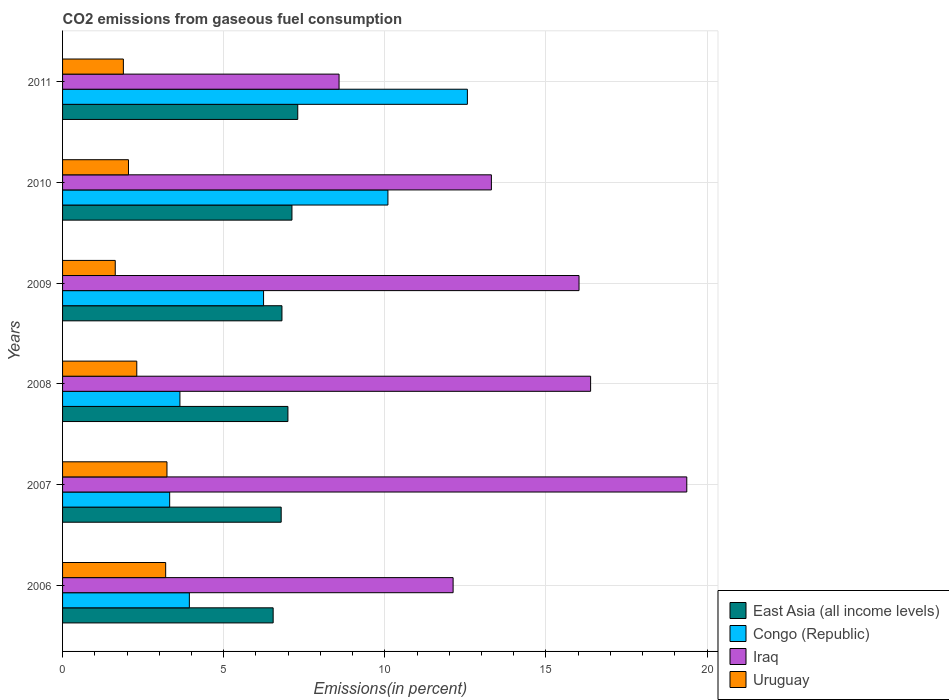How many different coloured bars are there?
Offer a very short reply. 4. How many groups of bars are there?
Ensure brevity in your answer.  6. How many bars are there on the 2nd tick from the bottom?
Offer a very short reply. 4. What is the label of the 1st group of bars from the top?
Keep it short and to the point. 2011. What is the total CO2 emitted in Congo (Republic) in 2009?
Give a very brief answer. 6.24. Across all years, what is the maximum total CO2 emitted in East Asia (all income levels)?
Ensure brevity in your answer.  7.3. Across all years, what is the minimum total CO2 emitted in Uruguay?
Keep it short and to the point. 1.63. In which year was the total CO2 emitted in East Asia (all income levels) maximum?
Offer a very short reply. 2011. What is the total total CO2 emitted in Iraq in the graph?
Ensure brevity in your answer.  85.78. What is the difference between the total CO2 emitted in Uruguay in 2007 and that in 2011?
Keep it short and to the point. 1.35. What is the difference between the total CO2 emitted in Iraq in 2006 and the total CO2 emitted in East Asia (all income levels) in 2007?
Give a very brief answer. 5.33. What is the average total CO2 emitted in Congo (Republic) per year?
Your answer should be compact. 6.63. In the year 2007, what is the difference between the total CO2 emitted in Uruguay and total CO2 emitted in Congo (Republic)?
Give a very brief answer. -0.08. In how many years, is the total CO2 emitted in Congo (Republic) greater than 13 %?
Offer a very short reply. 0. What is the ratio of the total CO2 emitted in Iraq in 2006 to that in 2008?
Keep it short and to the point. 0.74. Is the total CO2 emitted in East Asia (all income levels) in 2009 less than that in 2010?
Make the answer very short. Yes. Is the difference between the total CO2 emitted in Uruguay in 2008 and 2011 greater than the difference between the total CO2 emitted in Congo (Republic) in 2008 and 2011?
Offer a terse response. Yes. What is the difference between the highest and the second highest total CO2 emitted in Uruguay?
Your response must be concise. 0.04. What is the difference between the highest and the lowest total CO2 emitted in Uruguay?
Your response must be concise. 1.6. Is it the case that in every year, the sum of the total CO2 emitted in East Asia (all income levels) and total CO2 emitted in Iraq is greater than the sum of total CO2 emitted in Congo (Republic) and total CO2 emitted in Uruguay?
Keep it short and to the point. No. What does the 1st bar from the top in 2008 represents?
Offer a very short reply. Uruguay. What does the 4th bar from the bottom in 2008 represents?
Offer a terse response. Uruguay. How many bars are there?
Provide a succinct answer. 24. Are all the bars in the graph horizontal?
Offer a terse response. Yes. Are the values on the major ticks of X-axis written in scientific E-notation?
Your answer should be very brief. No. How many legend labels are there?
Make the answer very short. 4. How are the legend labels stacked?
Offer a very short reply. Vertical. What is the title of the graph?
Offer a terse response. CO2 emissions from gaseous fuel consumption. What is the label or title of the X-axis?
Your answer should be very brief. Emissions(in percent). What is the label or title of the Y-axis?
Your response must be concise. Years. What is the Emissions(in percent) in East Asia (all income levels) in 2006?
Your answer should be compact. 6.53. What is the Emissions(in percent) in Congo (Republic) in 2006?
Make the answer very short. 3.93. What is the Emissions(in percent) in Iraq in 2006?
Ensure brevity in your answer.  12.12. What is the Emissions(in percent) in Uruguay in 2006?
Your answer should be compact. 3.2. What is the Emissions(in percent) of East Asia (all income levels) in 2007?
Offer a very short reply. 6.78. What is the Emissions(in percent) of Congo (Republic) in 2007?
Your answer should be very brief. 3.32. What is the Emissions(in percent) of Iraq in 2007?
Give a very brief answer. 19.37. What is the Emissions(in percent) of Uruguay in 2007?
Make the answer very short. 3.24. What is the Emissions(in percent) of East Asia (all income levels) in 2008?
Your response must be concise. 6.99. What is the Emissions(in percent) of Congo (Republic) in 2008?
Your answer should be very brief. 3.64. What is the Emissions(in percent) in Iraq in 2008?
Your answer should be compact. 16.38. What is the Emissions(in percent) of Uruguay in 2008?
Offer a very short reply. 2.3. What is the Emissions(in percent) in East Asia (all income levels) in 2009?
Your answer should be compact. 6.81. What is the Emissions(in percent) in Congo (Republic) in 2009?
Give a very brief answer. 6.24. What is the Emissions(in percent) of Iraq in 2009?
Your answer should be compact. 16.03. What is the Emissions(in percent) in Uruguay in 2009?
Your answer should be compact. 1.63. What is the Emissions(in percent) in East Asia (all income levels) in 2010?
Your response must be concise. 7.12. What is the Emissions(in percent) of Congo (Republic) in 2010?
Make the answer very short. 10.1. What is the Emissions(in percent) of Iraq in 2010?
Keep it short and to the point. 13.31. What is the Emissions(in percent) in Uruguay in 2010?
Your answer should be very brief. 2.05. What is the Emissions(in percent) of East Asia (all income levels) in 2011?
Your answer should be compact. 7.3. What is the Emissions(in percent) of Congo (Republic) in 2011?
Your response must be concise. 12.56. What is the Emissions(in percent) in Iraq in 2011?
Provide a short and direct response. 8.58. What is the Emissions(in percent) of Uruguay in 2011?
Ensure brevity in your answer.  1.89. Across all years, what is the maximum Emissions(in percent) in East Asia (all income levels)?
Your answer should be very brief. 7.3. Across all years, what is the maximum Emissions(in percent) in Congo (Republic)?
Keep it short and to the point. 12.56. Across all years, what is the maximum Emissions(in percent) of Iraq?
Keep it short and to the point. 19.37. Across all years, what is the maximum Emissions(in percent) in Uruguay?
Ensure brevity in your answer.  3.24. Across all years, what is the minimum Emissions(in percent) of East Asia (all income levels)?
Provide a short and direct response. 6.53. Across all years, what is the minimum Emissions(in percent) in Congo (Republic)?
Ensure brevity in your answer.  3.32. Across all years, what is the minimum Emissions(in percent) of Iraq?
Your answer should be very brief. 8.58. Across all years, what is the minimum Emissions(in percent) in Uruguay?
Your answer should be very brief. 1.63. What is the total Emissions(in percent) in East Asia (all income levels) in the graph?
Ensure brevity in your answer.  41.53. What is the total Emissions(in percent) of Congo (Republic) in the graph?
Your answer should be compact. 39.79. What is the total Emissions(in percent) of Iraq in the graph?
Ensure brevity in your answer.  85.78. What is the total Emissions(in percent) in Uruguay in the graph?
Provide a short and direct response. 14.31. What is the difference between the Emissions(in percent) of East Asia (all income levels) in 2006 and that in 2007?
Give a very brief answer. -0.25. What is the difference between the Emissions(in percent) of Congo (Republic) in 2006 and that in 2007?
Offer a very short reply. 0.61. What is the difference between the Emissions(in percent) in Iraq in 2006 and that in 2007?
Your answer should be compact. -7.25. What is the difference between the Emissions(in percent) of Uruguay in 2006 and that in 2007?
Ensure brevity in your answer.  -0.04. What is the difference between the Emissions(in percent) in East Asia (all income levels) in 2006 and that in 2008?
Your response must be concise. -0.46. What is the difference between the Emissions(in percent) of Congo (Republic) in 2006 and that in 2008?
Your response must be concise. 0.29. What is the difference between the Emissions(in percent) in Iraq in 2006 and that in 2008?
Provide a succinct answer. -4.27. What is the difference between the Emissions(in percent) of Uruguay in 2006 and that in 2008?
Your response must be concise. 0.9. What is the difference between the Emissions(in percent) in East Asia (all income levels) in 2006 and that in 2009?
Make the answer very short. -0.27. What is the difference between the Emissions(in percent) in Congo (Republic) in 2006 and that in 2009?
Provide a succinct answer. -2.3. What is the difference between the Emissions(in percent) of Iraq in 2006 and that in 2009?
Offer a very short reply. -3.91. What is the difference between the Emissions(in percent) of Uruguay in 2006 and that in 2009?
Make the answer very short. 1.56. What is the difference between the Emissions(in percent) of East Asia (all income levels) in 2006 and that in 2010?
Your answer should be very brief. -0.58. What is the difference between the Emissions(in percent) of Congo (Republic) in 2006 and that in 2010?
Provide a short and direct response. -6.16. What is the difference between the Emissions(in percent) of Iraq in 2006 and that in 2010?
Make the answer very short. -1.19. What is the difference between the Emissions(in percent) of Uruguay in 2006 and that in 2010?
Keep it short and to the point. 1.15. What is the difference between the Emissions(in percent) of East Asia (all income levels) in 2006 and that in 2011?
Offer a very short reply. -0.76. What is the difference between the Emissions(in percent) of Congo (Republic) in 2006 and that in 2011?
Make the answer very short. -8.63. What is the difference between the Emissions(in percent) of Iraq in 2006 and that in 2011?
Provide a succinct answer. 3.54. What is the difference between the Emissions(in percent) in Uruguay in 2006 and that in 2011?
Provide a succinct answer. 1.31. What is the difference between the Emissions(in percent) of East Asia (all income levels) in 2007 and that in 2008?
Ensure brevity in your answer.  -0.21. What is the difference between the Emissions(in percent) of Congo (Republic) in 2007 and that in 2008?
Ensure brevity in your answer.  -0.32. What is the difference between the Emissions(in percent) in Iraq in 2007 and that in 2008?
Your answer should be compact. 2.98. What is the difference between the Emissions(in percent) in Uruguay in 2007 and that in 2008?
Keep it short and to the point. 0.94. What is the difference between the Emissions(in percent) in East Asia (all income levels) in 2007 and that in 2009?
Your response must be concise. -0.02. What is the difference between the Emissions(in percent) in Congo (Republic) in 2007 and that in 2009?
Provide a short and direct response. -2.91. What is the difference between the Emissions(in percent) of Iraq in 2007 and that in 2009?
Give a very brief answer. 3.34. What is the difference between the Emissions(in percent) of Uruguay in 2007 and that in 2009?
Provide a succinct answer. 1.6. What is the difference between the Emissions(in percent) of East Asia (all income levels) in 2007 and that in 2010?
Your answer should be very brief. -0.33. What is the difference between the Emissions(in percent) of Congo (Republic) in 2007 and that in 2010?
Provide a succinct answer. -6.77. What is the difference between the Emissions(in percent) of Iraq in 2007 and that in 2010?
Your response must be concise. 6.06. What is the difference between the Emissions(in percent) of Uruguay in 2007 and that in 2010?
Keep it short and to the point. 1.19. What is the difference between the Emissions(in percent) in East Asia (all income levels) in 2007 and that in 2011?
Keep it short and to the point. -0.51. What is the difference between the Emissions(in percent) of Congo (Republic) in 2007 and that in 2011?
Provide a succinct answer. -9.24. What is the difference between the Emissions(in percent) in Iraq in 2007 and that in 2011?
Your answer should be very brief. 10.79. What is the difference between the Emissions(in percent) of Uruguay in 2007 and that in 2011?
Give a very brief answer. 1.35. What is the difference between the Emissions(in percent) in East Asia (all income levels) in 2008 and that in 2009?
Offer a very short reply. 0.18. What is the difference between the Emissions(in percent) of Congo (Republic) in 2008 and that in 2009?
Your response must be concise. -2.6. What is the difference between the Emissions(in percent) in Iraq in 2008 and that in 2009?
Your answer should be compact. 0.36. What is the difference between the Emissions(in percent) in Uruguay in 2008 and that in 2009?
Provide a succinct answer. 0.67. What is the difference between the Emissions(in percent) in East Asia (all income levels) in 2008 and that in 2010?
Provide a succinct answer. -0.12. What is the difference between the Emissions(in percent) in Congo (Republic) in 2008 and that in 2010?
Offer a terse response. -6.45. What is the difference between the Emissions(in percent) in Iraq in 2008 and that in 2010?
Offer a very short reply. 3.08. What is the difference between the Emissions(in percent) of Uruguay in 2008 and that in 2010?
Keep it short and to the point. 0.26. What is the difference between the Emissions(in percent) in East Asia (all income levels) in 2008 and that in 2011?
Keep it short and to the point. -0.3. What is the difference between the Emissions(in percent) of Congo (Republic) in 2008 and that in 2011?
Offer a terse response. -8.92. What is the difference between the Emissions(in percent) in Iraq in 2008 and that in 2011?
Your answer should be compact. 7.81. What is the difference between the Emissions(in percent) in Uruguay in 2008 and that in 2011?
Offer a terse response. 0.42. What is the difference between the Emissions(in percent) in East Asia (all income levels) in 2009 and that in 2010?
Offer a very short reply. -0.31. What is the difference between the Emissions(in percent) of Congo (Republic) in 2009 and that in 2010?
Your answer should be very brief. -3.86. What is the difference between the Emissions(in percent) of Iraq in 2009 and that in 2010?
Provide a succinct answer. 2.72. What is the difference between the Emissions(in percent) in Uruguay in 2009 and that in 2010?
Make the answer very short. -0.41. What is the difference between the Emissions(in percent) in East Asia (all income levels) in 2009 and that in 2011?
Offer a terse response. -0.49. What is the difference between the Emissions(in percent) of Congo (Republic) in 2009 and that in 2011?
Ensure brevity in your answer.  -6.32. What is the difference between the Emissions(in percent) of Iraq in 2009 and that in 2011?
Provide a short and direct response. 7.45. What is the difference between the Emissions(in percent) of Uruguay in 2009 and that in 2011?
Give a very brief answer. -0.25. What is the difference between the Emissions(in percent) in East Asia (all income levels) in 2010 and that in 2011?
Keep it short and to the point. -0.18. What is the difference between the Emissions(in percent) of Congo (Republic) in 2010 and that in 2011?
Give a very brief answer. -2.47. What is the difference between the Emissions(in percent) in Iraq in 2010 and that in 2011?
Make the answer very short. 4.73. What is the difference between the Emissions(in percent) of Uruguay in 2010 and that in 2011?
Provide a short and direct response. 0.16. What is the difference between the Emissions(in percent) of East Asia (all income levels) in 2006 and the Emissions(in percent) of Congo (Republic) in 2007?
Offer a very short reply. 3.21. What is the difference between the Emissions(in percent) in East Asia (all income levels) in 2006 and the Emissions(in percent) in Iraq in 2007?
Keep it short and to the point. -12.83. What is the difference between the Emissions(in percent) in East Asia (all income levels) in 2006 and the Emissions(in percent) in Uruguay in 2007?
Offer a very short reply. 3.29. What is the difference between the Emissions(in percent) in Congo (Republic) in 2006 and the Emissions(in percent) in Iraq in 2007?
Offer a very short reply. -15.43. What is the difference between the Emissions(in percent) in Congo (Republic) in 2006 and the Emissions(in percent) in Uruguay in 2007?
Your answer should be compact. 0.69. What is the difference between the Emissions(in percent) of Iraq in 2006 and the Emissions(in percent) of Uruguay in 2007?
Offer a terse response. 8.88. What is the difference between the Emissions(in percent) in East Asia (all income levels) in 2006 and the Emissions(in percent) in Congo (Republic) in 2008?
Offer a very short reply. 2.89. What is the difference between the Emissions(in percent) in East Asia (all income levels) in 2006 and the Emissions(in percent) in Iraq in 2008?
Ensure brevity in your answer.  -9.85. What is the difference between the Emissions(in percent) of East Asia (all income levels) in 2006 and the Emissions(in percent) of Uruguay in 2008?
Provide a succinct answer. 4.23. What is the difference between the Emissions(in percent) of Congo (Republic) in 2006 and the Emissions(in percent) of Iraq in 2008?
Give a very brief answer. -12.45. What is the difference between the Emissions(in percent) of Congo (Republic) in 2006 and the Emissions(in percent) of Uruguay in 2008?
Make the answer very short. 1.63. What is the difference between the Emissions(in percent) in Iraq in 2006 and the Emissions(in percent) in Uruguay in 2008?
Your answer should be compact. 9.82. What is the difference between the Emissions(in percent) of East Asia (all income levels) in 2006 and the Emissions(in percent) of Congo (Republic) in 2009?
Make the answer very short. 0.3. What is the difference between the Emissions(in percent) of East Asia (all income levels) in 2006 and the Emissions(in percent) of Iraq in 2009?
Your answer should be very brief. -9.49. What is the difference between the Emissions(in percent) in East Asia (all income levels) in 2006 and the Emissions(in percent) in Uruguay in 2009?
Your answer should be very brief. 4.9. What is the difference between the Emissions(in percent) in Congo (Republic) in 2006 and the Emissions(in percent) in Iraq in 2009?
Provide a short and direct response. -12.09. What is the difference between the Emissions(in percent) in Congo (Republic) in 2006 and the Emissions(in percent) in Uruguay in 2009?
Keep it short and to the point. 2.3. What is the difference between the Emissions(in percent) of Iraq in 2006 and the Emissions(in percent) of Uruguay in 2009?
Offer a very short reply. 10.48. What is the difference between the Emissions(in percent) in East Asia (all income levels) in 2006 and the Emissions(in percent) in Congo (Republic) in 2010?
Your answer should be compact. -3.56. What is the difference between the Emissions(in percent) of East Asia (all income levels) in 2006 and the Emissions(in percent) of Iraq in 2010?
Offer a terse response. -6.77. What is the difference between the Emissions(in percent) in East Asia (all income levels) in 2006 and the Emissions(in percent) in Uruguay in 2010?
Your answer should be compact. 4.49. What is the difference between the Emissions(in percent) of Congo (Republic) in 2006 and the Emissions(in percent) of Iraq in 2010?
Provide a short and direct response. -9.37. What is the difference between the Emissions(in percent) in Congo (Republic) in 2006 and the Emissions(in percent) in Uruguay in 2010?
Offer a terse response. 1.89. What is the difference between the Emissions(in percent) in Iraq in 2006 and the Emissions(in percent) in Uruguay in 2010?
Keep it short and to the point. 10.07. What is the difference between the Emissions(in percent) of East Asia (all income levels) in 2006 and the Emissions(in percent) of Congo (Republic) in 2011?
Give a very brief answer. -6.03. What is the difference between the Emissions(in percent) in East Asia (all income levels) in 2006 and the Emissions(in percent) in Iraq in 2011?
Offer a terse response. -2.04. What is the difference between the Emissions(in percent) in East Asia (all income levels) in 2006 and the Emissions(in percent) in Uruguay in 2011?
Offer a terse response. 4.65. What is the difference between the Emissions(in percent) of Congo (Republic) in 2006 and the Emissions(in percent) of Iraq in 2011?
Provide a short and direct response. -4.64. What is the difference between the Emissions(in percent) in Congo (Republic) in 2006 and the Emissions(in percent) in Uruguay in 2011?
Make the answer very short. 2.05. What is the difference between the Emissions(in percent) in Iraq in 2006 and the Emissions(in percent) in Uruguay in 2011?
Keep it short and to the point. 10.23. What is the difference between the Emissions(in percent) in East Asia (all income levels) in 2007 and the Emissions(in percent) in Congo (Republic) in 2008?
Offer a very short reply. 3.14. What is the difference between the Emissions(in percent) in East Asia (all income levels) in 2007 and the Emissions(in percent) in Iraq in 2008?
Your answer should be very brief. -9.6. What is the difference between the Emissions(in percent) of East Asia (all income levels) in 2007 and the Emissions(in percent) of Uruguay in 2008?
Provide a short and direct response. 4.48. What is the difference between the Emissions(in percent) of Congo (Republic) in 2007 and the Emissions(in percent) of Iraq in 2008?
Offer a terse response. -13.06. What is the difference between the Emissions(in percent) in Congo (Republic) in 2007 and the Emissions(in percent) in Uruguay in 2008?
Keep it short and to the point. 1.02. What is the difference between the Emissions(in percent) of Iraq in 2007 and the Emissions(in percent) of Uruguay in 2008?
Provide a short and direct response. 17.07. What is the difference between the Emissions(in percent) of East Asia (all income levels) in 2007 and the Emissions(in percent) of Congo (Republic) in 2009?
Give a very brief answer. 0.55. What is the difference between the Emissions(in percent) in East Asia (all income levels) in 2007 and the Emissions(in percent) in Iraq in 2009?
Provide a succinct answer. -9.24. What is the difference between the Emissions(in percent) of East Asia (all income levels) in 2007 and the Emissions(in percent) of Uruguay in 2009?
Your answer should be very brief. 5.15. What is the difference between the Emissions(in percent) of Congo (Republic) in 2007 and the Emissions(in percent) of Iraq in 2009?
Your answer should be very brief. -12.7. What is the difference between the Emissions(in percent) in Congo (Republic) in 2007 and the Emissions(in percent) in Uruguay in 2009?
Give a very brief answer. 1.69. What is the difference between the Emissions(in percent) in Iraq in 2007 and the Emissions(in percent) in Uruguay in 2009?
Give a very brief answer. 17.73. What is the difference between the Emissions(in percent) of East Asia (all income levels) in 2007 and the Emissions(in percent) of Congo (Republic) in 2010?
Your answer should be compact. -3.31. What is the difference between the Emissions(in percent) in East Asia (all income levels) in 2007 and the Emissions(in percent) in Iraq in 2010?
Make the answer very short. -6.52. What is the difference between the Emissions(in percent) in East Asia (all income levels) in 2007 and the Emissions(in percent) in Uruguay in 2010?
Your answer should be very brief. 4.74. What is the difference between the Emissions(in percent) of Congo (Republic) in 2007 and the Emissions(in percent) of Iraq in 2010?
Make the answer very short. -9.98. What is the difference between the Emissions(in percent) in Congo (Republic) in 2007 and the Emissions(in percent) in Uruguay in 2010?
Give a very brief answer. 1.28. What is the difference between the Emissions(in percent) of Iraq in 2007 and the Emissions(in percent) of Uruguay in 2010?
Offer a terse response. 17.32. What is the difference between the Emissions(in percent) in East Asia (all income levels) in 2007 and the Emissions(in percent) in Congo (Republic) in 2011?
Your answer should be compact. -5.78. What is the difference between the Emissions(in percent) in East Asia (all income levels) in 2007 and the Emissions(in percent) in Iraq in 2011?
Make the answer very short. -1.8. What is the difference between the Emissions(in percent) in East Asia (all income levels) in 2007 and the Emissions(in percent) in Uruguay in 2011?
Provide a short and direct response. 4.9. What is the difference between the Emissions(in percent) in Congo (Republic) in 2007 and the Emissions(in percent) in Iraq in 2011?
Keep it short and to the point. -5.26. What is the difference between the Emissions(in percent) of Congo (Republic) in 2007 and the Emissions(in percent) of Uruguay in 2011?
Provide a succinct answer. 1.44. What is the difference between the Emissions(in percent) in Iraq in 2007 and the Emissions(in percent) in Uruguay in 2011?
Keep it short and to the point. 17.48. What is the difference between the Emissions(in percent) in East Asia (all income levels) in 2008 and the Emissions(in percent) in Congo (Republic) in 2009?
Provide a short and direct response. 0.76. What is the difference between the Emissions(in percent) of East Asia (all income levels) in 2008 and the Emissions(in percent) of Iraq in 2009?
Ensure brevity in your answer.  -9.03. What is the difference between the Emissions(in percent) in East Asia (all income levels) in 2008 and the Emissions(in percent) in Uruguay in 2009?
Provide a short and direct response. 5.36. What is the difference between the Emissions(in percent) in Congo (Republic) in 2008 and the Emissions(in percent) in Iraq in 2009?
Give a very brief answer. -12.38. What is the difference between the Emissions(in percent) of Congo (Republic) in 2008 and the Emissions(in percent) of Uruguay in 2009?
Provide a succinct answer. 2.01. What is the difference between the Emissions(in percent) of Iraq in 2008 and the Emissions(in percent) of Uruguay in 2009?
Offer a very short reply. 14.75. What is the difference between the Emissions(in percent) in East Asia (all income levels) in 2008 and the Emissions(in percent) in Congo (Republic) in 2010?
Your answer should be very brief. -3.1. What is the difference between the Emissions(in percent) of East Asia (all income levels) in 2008 and the Emissions(in percent) of Iraq in 2010?
Give a very brief answer. -6.31. What is the difference between the Emissions(in percent) in East Asia (all income levels) in 2008 and the Emissions(in percent) in Uruguay in 2010?
Your answer should be compact. 4.95. What is the difference between the Emissions(in percent) of Congo (Republic) in 2008 and the Emissions(in percent) of Iraq in 2010?
Provide a short and direct response. -9.66. What is the difference between the Emissions(in percent) in Congo (Republic) in 2008 and the Emissions(in percent) in Uruguay in 2010?
Offer a terse response. 1.6. What is the difference between the Emissions(in percent) in Iraq in 2008 and the Emissions(in percent) in Uruguay in 2010?
Offer a terse response. 14.34. What is the difference between the Emissions(in percent) in East Asia (all income levels) in 2008 and the Emissions(in percent) in Congo (Republic) in 2011?
Keep it short and to the point. -5.57. What is the difference between the Emissions(in percent) in East Asia (all income levels) in 2008 and the Emissions(in percent) in Iraq in 2011?
Provide a short and direct response. -1.59. What is the difference between the Emissions(in percent) in East Asia (all income levels) in 2008 and the Emissions(in percent) in Uruguay in 2011?
Keep it short and to the point. 5.11. What is the difference between the Emissions(in percent) of Congo (Republic) in 2008 and the Emissions(in percent) of Iraq in 2011?
Provide a succinct answer. -4.94. What is the difference between the Emissions(in percent) of Congo (Republic) in 2008 and the Emissions(in percent) of Uruguay in 2011?
Your answer should be compact. 1.75. What is the difference between the Emissions(in percent) in Iraq in 2008 and the Emissions(in percent) in Uruguay in 2011?
Give a very brief answer. 14.5. What is the difference between the Emissions(in percent) in East Asia (all income levels) in 2009 and the Emissions(in percent) in Congo (Republic) in 2010?
Your answer should be compact. -3.29. What is the difference between the Emissions(in percent) of East Asia (all income levels) in 2009 and the Emissions(in percent) of Iraq in 2010?
Give a very brief answer. -6.5. What is the difference between the Emissions(in percent) in East Asia (all income levels) in 2009 and the Emissions(in percent) in Uruguay in 2010?
Give a very brief answer. 4.76. What is the difference between the Emissions(in percent) of Congo (Republic) in 2009 and the Emissions(in percent) of Iraq in 2010?
Make the answer very short. -7.07. What is the difference between the Emissions(in percent) of Congo (Republic) in 2009 and the Emissions(in percent) of Uruguay in 2010?
Your response must be concise. 4.19. What is the difference between the Emissions(in percent) of Iraq in 2009 and the Emissions(in percent) of Uruguay in 2010?
Keep it short and to the point. 13.98. What is the difference between the Emissions(in percent) of East Asia (all income levels) in 2009 and the Emissions(in percent) of Congo (Republic) in 2011?
Your answer should be very brief. -5.75. What is the difference between the Emissions(in percent) of East Asia (all income levels) in 2009 and the Emissions(in percent) of Iraq in 2011?
Your answer should be very brief. -1.77. What is the difference between the Emissions(in percent) in East Asia (all income levels) in 2009 and the Emissions(in percent) in Uruguay in 2011?
Keep it short and to the point. 4.92. What is the difference between the Emissions(in percent) in Congo (Republic) in 2009 and the Emissions(in percent) in Iraq in 2011?
Offer a very short reply. -2.34. What is the difference between the Emissions(in percent) of Congo (Republic) in 2009 and the Emissions(in percent) of Uruguay in 2011?
Offer a very short reply. 4.35. What is the difference between the Emissions(in percent) in Iraq in 2009 and the Emissions(in percent) in Uruguay in 2011?
Provide a short and direct response. 14.14. What is the difference between the Emissions(in percent) of East Asia (all income levels) in 2010 and the Emissions(in percent) of Congo (Republic) in 2011?
Your answer should be compact. -5.44. What is the difference between the Emissions(in percent) in East Asia (all income levels) in 2010 and the Emissions(in percent) in Iraq in 2011?
Your answer should be very brief. -1.46. What is the difference between the Emissions(in percent) of East Asia (all income levels) in 2010 and the Emissions(in percent) of Uruguay in 2011?
Provide a short and direct response. 5.23. What is the difference between the Emissions(in percent) of Congo (Republic) in 2010 and the Emissions(in percent) of Iraq in 2011?
Offer a terse response. 1.52. What is the difference between the Emissions(in percent) of Congo (Republic) in 2010 and the Emissions(in percent) of Uruguay in 2011?
Offer a terse response. 8.21. What is the difference between the Emissions(in percent) in Iraq in 2010 and the Emissions(in percent) in Uruguay in 2011?
Your answer should be compact. 11.42. What is the average Emissions(in percent) in East Asia (all income levels) per year?
Provide a succinct answer. 6.92. What is the average Emissions(in percent) of Congo (Republic) per year?
Your answer should be compact. 6.63. What is the average Emissions(in percent) in Iraq per year?
Give a very brief answer. 14.3. What is the average Emissions(in percent) of Uruguay per year?
Give a very brief answer. 2.38. In the year 2006, what is the difference between the Emissions(in percent) of East Asia (all income levels) and Emissions(in percent) of Congo (Republic)?
Offer a terse response. 2.6. In the year 2006, what is the difference between the Emissions(in percent) in East Asia (all income levels) and Emissions(in percent) in Iraq?
Your response must be concise. -5.58. In the year 2006, what is the difference between the Emissions(in percent) in East Asia (all income levels) and Emissions(in percent) in Uruguay?
Offer a terse response. 3.34. In the year 2006, what is the difference between the Emissions(in percent) of Congo (Republic) and Emissions(in percent) of Iraq?
Provide a short and direct response. -8.18. In the year 2006, what is the difference between the Emissions(in percent) of Congo (Republic) and Emissions(in percent) of Uruguay?
Offer a very short reply. 0.74. In the year 2006, what is the difference between the Emissions(in percent) in Iraq and Emissions(in percent) in Uruguay?
Your answer should be compact. 8.92. In the year 2007, what is the difference between the Emissions(in percent) in East Asia (all income levels) and Emissions(in percent) in Congo (Republic)?
Ensure brevity in your answer.  3.46. In the year 2007, what is the difference between the Emissions(in percent) of East Asia (all income levels) and Emissions(in percent) of Iraq?
Offer a terse response. -12.59. In the year 2007, what is the difference between the Emissions(in percent) of East Asia (all income levels) and Emissions(in percent) of Uruguay?
Your answer should be very brief. 3.54. In the year 2007, what is the difference between the Emissions(in percent) of Congo (Republic) and Emissions(in percent) of Iraq?
Provide a short and direct response. -16.05. In the year 2007, what is the difference between the Emissions(in percent) of Congo (Republic) and Emissions(in percent) of Uruguay?
Offer a terse response. 0.08. In the year 2007, what is the difference between the Emissions(in percent) of Iraq and Emissions(in percent) of Uruguay?
Your answer should be very brief. 16.13. In the year 2008, what is the difference between the Emissions(in percent) in East Asia (all income levels) and Emissions(in percent) in Congo (Republic)?
Give a very brief answer. 3.35. In the year 2008, what is the difference between the Emissions(in percent) in East Asia (all income levels) and Emissions(in percent) in Iraq?
Your answer should be very brief. -9.39. In the year 2008, what is the difference between the Emissions(in percent) in East Asia (all income levels) and Emissions(in percent) in Uruguay?
Your response must be concise. 4.69. In the year 2008, what is the difference between the Emissions(in percent) of Congo (Republic) and Emissions(in percent) of Iraq?
Give a very brief answer. -12.74. In the year 2008, what is the difference between the Emissions(in percent) in Congo (Republic) and Emissions(in percent) in Uruguay?
Give a very brief answer. 1.34. In the year 2008, what is the difference between the Emissions(in percent) in Iraq and Emissions(in percent) in Uruguay?
Offer a very short reply. 14.08. In the year 2009, what is the difference between the Emissions(in percent) of East Asia (all income levels) and Emissions(in percent) of Congo (Republic)?
Keep it short and to the point. 0.57. In the year 2009, what is the difference between the Emissions(in percent) of East Asia (all income levels) and Emissions(in percent) of Iraq?
Offer a terse response. -9.22. In the year 2009, what is the difference between the Emissions(in percent) of East Asia (all income levels) and Emissions(in percent) of Uruguay?
Your answer should be very brief. 5.17. In the year 2009, what is the difference between the Emissions(in percent) of Congo (Republic) and Emissions(in percent) of Iraq?
Provide a short and direct response. -9.79. In the year 2009, what is the difference between the Emissions(in percent) in Congo (Republic) and Emissions(in percent) in Uruguay?
Provide a succinct answer. 4.6. In the year 2009, what is the difference between the Emissions(in percent) in Iraq and Emissions(in percent) in Uruguay?
Your answer should be very brief. 14.39. In the year 2010, what is the difference between the Emissions(in percent) in East Asia (all income levels) and Emissions(in percent) in Congo (Republic)?
Make the answer very short. -2.98. In the year 2010, what is the difference between the Emissions(in percent) in East Asia (all income levels) and Emissions(in percent) in Iraq?
Ensure brevity in your answer.  -6.19. In the year 2010, what is the difference between the Emissions(in percent) of East Asia (all income levels) and Emissions(in percent) of Uruguay?
Keep it short and to the point. 5.07. In the year 2010, what is the difference between the Emissions(in percent) in Congo (Republic) and Emissions(in percent) in Iraq?
Offer a very short reply. -3.21. In the year 2010, what is the difference between the Emissions(in percent) in Congo (Republic) and Emissions(in percent) in Uruguay?
Give a very brief answer. 8.05. In the year 2010, what is the difference between the Emissions(in percent) in Iraq and Emissions(in percent) in Uruguay?
Make the answer very short. 11.26. In the year 2011, what is the difference between the Emissions(in percent) in East Asia (all income levels) and Emissions(in percent) in Congo (Republic)?
Provide a succinct answer. -5.26. In the year 2011, what is the difference between the Emissions(in percent) in East Asia (all income levels) and Emissions(in percent) in Iraq?
Provide a short and direct response. -1.28. In the year 2011, what is the difference between the Emissions(in percent) of East Asia (all income levels) and Emissions(in percent) of Uruguay?
Provide a short and direct response. 5.41. In the year 2011, what is the difference between the Emissions(in percent) in Congo (Republic) and Emissions(in percent) in Iraq?
Your response must be concise. 3.98. In the year 2011, what is the difference between the Emissions(in percent) in Congo (Republic) and Emissions(in percent) in Uruguay?
Offer a terse response. 10.67. In the year 2011, what is the difference between the Emissions(in percent) of Iraq and Emissions(in percent) of Uruguay?
Make the answer very short. 6.69. What is the ratio of the Emissions(in percent) of East Asia (all income levels) in 2006 to that in 2007?
Provide a succinct answer. 0.96. What is the ratio of the Emissions(in percent) in Congo (Republic) in 2006 to that in 2007?
Ensure brevity in your answer.  1.18. What is the ratio of the Emissions(in percent) in Iraq in 2006 to that in 2007?
Your response must be concise. 0.63. What is the ratio of the Emissions(in percent) in Uruguay in 2006 to that in 2007?
Offer a very short reply. 0.99. What is the ratio of the Emissions(in percent) of East Asia (all income levels) in 2006 to that in 2008?
Provide a short and direct response. 0.93. What is the ratio of the Emissions(in percent) in Congo (Republic) in 2006 to that in 2008?
Your answer should be compact. 1.08. What is the ratio of the Emissions(in percent) of Iraq in 2006 to that in 2008?
Offer a terse response. 0.74. What is the ratio of the Emissions(in percent) of Uruguay in 2006 to that in 2008?
Offer a terse response. 1.39. What is the ratio of the Emissions(in percent) of East Asia (all income levels) in 2006 to that in 2009?
Provide a short and direct response. 0.96. What is the ratio of the Emissions(in percent) in Congo (Republic) in 2006 to that in 2009?
Make the answer very short. 0.63. What is the ratio of the Emissions(in percent) of Iraq in 2006 to that in 2009?
Offer a very short reply. 0.76. What is the ratio of the Emissions(in percent) of Uruguay in 2006 to that in 2009?
Give a very brief answer. 1.96. What is the ratio of the Emissions(in percent) in East Asia (all income levels) in 2006 to that in 2010?
Ensure brevity in your answer.  0.92. What is the ratio of the Emissions(in percent) in Congo (Republic) in 2006 to that in 2010?
Give a very brief answer. 0.39. What is the ratio of the Emissions(in percent) in Iraq in 2006 to that in 2010?
Your response must be concise. 0.91. What is the ratio of the Emissions(in percent) in Uruguay in 2006 to that in 2010?
Make the answer very short. 1.56. What is the ratio of the Emissions(in percent) in East Asia (all income levels) in 2006 to that in 2011?
Ensure brevity in your answer.  0.9. What is the ratio of the Emissions(in percent) in Congo (Republic) in 2006 to that in 2011?
Give a very brief answer. 0.31. What is the ratio of the Emissions(in percent) in Iraq in 2006 to that in 2011?
Make the answer very short. 1.41. What is the ratio of the Emissions(in percent) of Uruguay in 2006 to that in 2011?
Offer a very short reply. 1.7. What is the ratio of the Emissions(in percent) in East Asia (all income levels) in 2007 to that in 2008?
Your answer should be very brief. 0.97. What is the ratio of the Emissions(in percent) in Congo (Republic) in 2007 to that in 2008?
Ensure brevity in your answer.  0.91. What is the ratio of the Emissions(in percent) of Iraq in 2007 to that in 2008?
Your answer should be very brief. 1.18. What is the ratio of the Emissions(in percent) in Uruguay in 2007 to that in 2008?
Make the answer very short. 1.41. What is the ratio of the Emissions(in percent) in Congo (Republic) in 2007 to that in 2009?
Your answer should be compact. 0.53. What is the ratio of the Emissions(in percent) of Iraq in 2007 to that in 2009?
Your answer should be very brief. 1.21. What is the ratio of the Emissions(in percent) of Uruguay in 2007 to that in 2009?
Keep it short and to the point. 1.98. What is the ratio of the Emissions(in percent) in East Asia (all income levels) in 2007 to that in 2010?
Your answer should be compact. 0.95. What is the ratio of the Emissions(in percent) in Congo (Republic) in 2007 to that in 2010?
Offer a very short reply. 0.33. What is the ratio of the Emissions(in percent) of Iraq in 2007 to that in 2010?
Your answer should be very brief. 1.46. What is the ratio of the Emissions(in percent) in Uruguay in 2007 to that in 2010?
Make the answer very short. 1.58. What is the ratio of the Emissions(in percent) in East Asia (all income levels) in 2007 to that in 2011?
Provide a succinct answer. 0.93. What is the ratio of the Emissions(in percent) in Congo (Republic) in 2007 to that in 2011?
Ensure brevity in your answer.  0.26. What is the ratio of the Emissions(in percent) of Iraq in 2007 to that in 2011?
Provide a succinct answer. 2.26. What is the ratio of the Emissions(in percent) in Uruguay in 2007 to that in 2011?
Provide a succinct answer. 1.72. What is the ratio of the Emissions(in percent) of East Asia (all income levels) in 2008 to that in 2009?
Offer a very short reply. 1.03. What is the ratio of the Emissions(in percent) of Congo (Republic) in 2008 to that in 2009?
Offer a very short reply. 0.58. What is the ratio of the Emissions(in percent) in Iraq in 2008 to that in 2009?
Keep it short and to the point. 1.02. What is the ratio of the Emissions(in percent) of Uruguay in 2008 to that in 2009?
Give a very brief answer. 1.41. What is the ratio of the Emissions(in percent) in East Asia (all income levels) in 2008 to that in 2010?
Your answer should be very brief. 0.98. What is the ratio of the Emissions(in percent) of Congo (Republic) in 2008 to that in 2010?
Offer a very short reply. 0.36. What is the ratio of the Emissions(in percent) in Iraq in 2008 to that in 2010?
Give a very brief answer. 1.23. What is the ratio of the Emissions(in percent) of Uruguay in 2008 to that in 2010?
Offer a very short reply. 1.13. What is the ratio of the Emissions(in percent) of East Asia (all income levels) in 2008 to that in 2011?
Offer a very short reply. 0.96. What is the ratio of the Emissions(in percent) in Congo (Republic) in 2008 to that in 2011?
Give a very brief answer. 0.29. What is the ratio of the Emissions(in percent) of Iraq in 2008 to that in 2011?
Offer a terse response. 1.91. What is the ratio of the Emissions(in percent) of Uruguay in 2008 to that in 2011?
Your answer should be very brief. 1.22. What is the ratio of the Emissions(in percent) in East Asia (all income levels) in 2009 to that in 2010?
Offer a very short reply. 0.96. What is the ratio of the Emissions(in percent) of Congo (Republic) in 2009 to that in 2010?
Your answer should be compact. 0.62. What is the ratio of the Emissions(in percent) of Iraq in 2009 to that in 2010?
Ensure brevity in your answer.  1.2. What is the ratio of the Emissions(in percent) in Uruguay in 2009 to that in 2010?
Provide a succinct answer. 0.8. What is the ratio of the Emissions(in percent) of East Asia (all income levels) in 2009 to that in 2011?
Make the answer very short. 0.93. What is the ratio of the Emissions(in percent) in Congo (Republic) in 2009 to that in 2011?
Your answer should be very brief. 0.5. What is the ratio of the Emissions(in percent) in Iraq in 2009 to that in 2011?
Provide a succinct answer. 1.87. What is the ratio of the Emissions(in percent) in Uruguay in 2009 to that in 2011?
Give a very brief answer. 0.87. What is the ratio of the Emissions(in percent) in East Asia (all income levels) in 2010 to that in 2011?
Your answer should be compact. 0.98. What is the ratio of the Emissions(in percent) of Congo (Republic) in 2010 to that in 2011?
Give a very brief answer. 0.8. What is the ratio of the Emissions(in percent) of Iraq in 2010 to that in 2011?
Keep it short and to the point. 1.55. What is the ratio of the Emissions(in percent) of Uruguay in 2010 to that in 2011?
Your response must be concise. 1.08. What is the difference between the highest and the second highest Emissions(in percent) in East Asia (all income levels)?
Give a very brief answer. 0.18. What is the difference between the highest and the second highest Emissions(in percent) of Congo (Republic)?
Ensure brevity in your answer.  2.47. What is the difference between the highest and the second highest Emissions(in percent) in Iraq?
Your response must be concise. 2.98. What is the difference between the highest and the second highest Emissions(in percent) of Uruguay?
Offer a very short reply. 0.04. What is the difference between the highest and the lowest Emissions(in percent) of East Asia (all income levels)?
Your response must be concise. 0.76. What is the difference between the highest and the lowest Emissions(in percent) of Congo (Republic)?
Your answer should be compact. 9.24. What is the difference between the highest and the lowest Emissions(in percent) of Iraq?
Give a very brief answer. 10.79. What is the difference between the highest and the lowest Emissions(in percent) of Uruguay?
Your answer should be very brief. 1.6. 